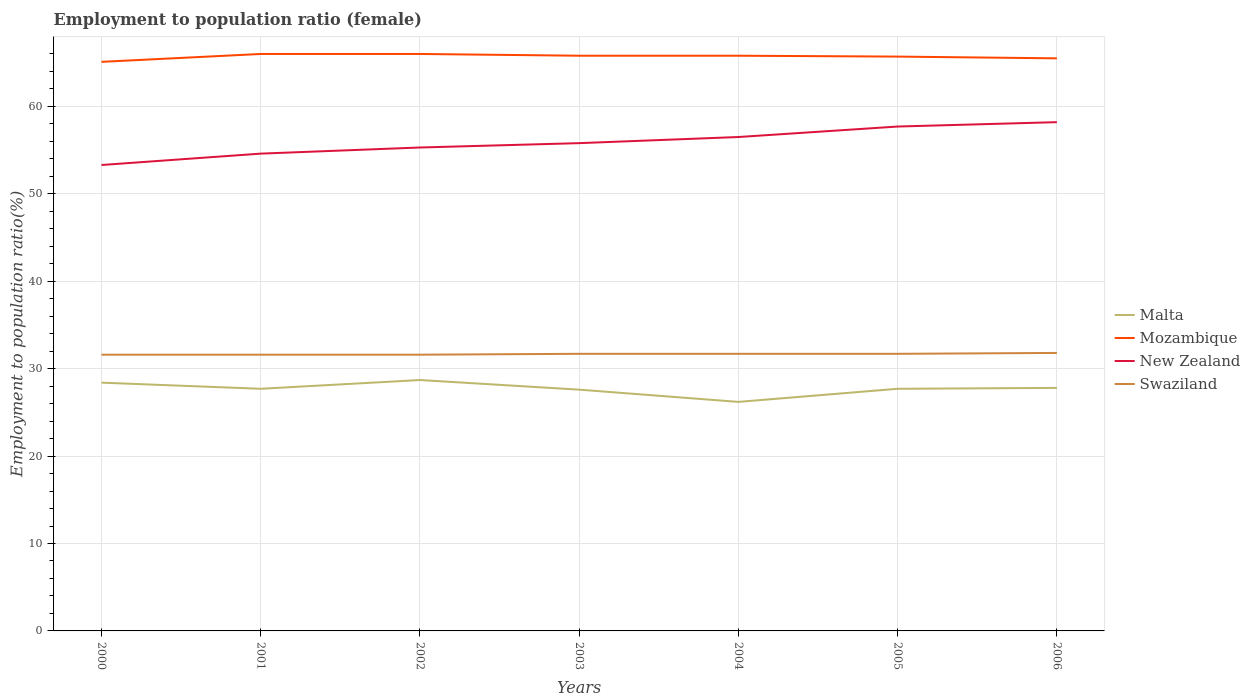How many different coloured lines are there?
Ensure brevity in your answer.  4. Does the line corresponding to Swaziland intersect with the line corresponding to Mozambique?
Your response must be concise. No. Across all years, what is the maximum employment to population ratio in New Zealand?
Your answer should be compact. 53.3. In which year was the employment to population ratio in Mozambique maximum?
Give a very brief answer. 2000. What is the total employment to population ratio in Mozambique in the graph?
Provide a short and direct response. 0.1. What is the difference between the highest and the second highest employment to population ratio in Mozambique?
Offer a terse response. 0.9. What is the difference between the highest and the lowest employment to population ratio in Mozambique?
Your answer should be very brief. 4. Is the employment to population ratio in New Zealand strictly greater than the employment to population ratio in Mozambique over the years?
Your answer should be very brief. Yes. What is the difference between two consecutive major ticks on the Y-axis?
Your answer should be very brief. 10. Are the values on the major ticks of Y-axis written in scientific E-notation?
Keep it short and to the point. No. Where does the legend appear in the graph?
Give a very brief answer. Center right. How many legend labels are there?
Offer a very short reply. 4. How are the legend labels stacked?
Keep it short and to the point. Vertical. What is the title of the graph?
Your answer should be compact. Employment to population ratio (female). Does "Qatar" appear as one of the legend labels in the graph?
Provide a succinct answer. No. What is the label or title of the X-axis?
Offer a terse response. Years. What is the Employment to population ratio(%) of Malta in 2000?
Offer a very short reply. 28.4. What is the Employment to population ratio(%) in Mozambique in 2000?
Offer a very short reply. 65.1. What is the Employment to population ratio(%) in New Zealand in 2000?
Keep it short and to the point. 53.3. What is the Employment to population ratio(%) in Swaziland in 2000?
Make the answer very short. 31.6. What is the Employment to population ratio(%) of Malta in 2001?
Your answer should be compact. 27.7. What is the Employment to population ratio(%) of New Zealand in 2001?
Provide a short and direct response. 54.6. What is the Employment to population ratio(%) in Swaziland in 2001?
Offer a terse response. 31.6. What is the Employment to population ratio(%) of Malta in 2002?
Ensure brevity in your answer.  28.7. What is the Employment to population ratio(%) of Mozambique in 2002?
Provide a succinct answer. 66. What is the Employment to population ratio(%) in New Zealand in 2002?
Provide a succinct answer. 55.3. What is the Employment to population ratio(%) of Swaziland in 2002?
Give a very brief answer. 31.6. What is the Employment to population ratio(%) of Malta in 2003?
Your answer should be very brief. 27.6. What is the Employment to population ratio(%) of Mozambique in 2003?
Your answer should be very brief. 65.8. What is the Employment to population ratio(%) in New Zealand in 2003?
Provide a succinct answer. 55.8. What is the Employment to population ratio(%) in Swaziland in 2003?
Make the answer very short. 31.7. What is the Employment to population ratio(%) in Malta in 2004?
Offer a very short reply. 26.2. What is the Employment to population ratio(%) in Mozambique in 2004?
Offer a very short reply. 65.8. What is the Employment to population ratio(%) in New Zealand in 2004?
Provide a short and direct response. 56.5. What is the Employment to population ratio(%) in Swaziland in 2004?
Keep it short and to the point. 31.7. What is the Employment to population ratio(%) in Malta in 2005?
Your response must be concise. 27.7. What is the Employment to population ratio(%) in Mozambique in 2005?
Provide a succinct answer. 65.7. What is the Employment to population ratio(%) of New Zealand in 2005?
Offer a terse response. 57.7. What is the Employment to population ratio(%) in Swaziland in 2005?
Your answer should be compact. 31.7. What is the Employment to population ratio(%) in Malta in 2006?
Your response must be concise. 27.8. What is the Employment to population ratio(%) in Mozambique in 2006?
Your response must be concise. 65.5. What is the Employment to population ratio(%) of New Zealand in 2006?
Ensure brevity in your answer.  58.2. What is the Employment to population ratio(%) in Swaziland in 2006?
Provide a succinct answer. 31.8. Across all years, what is the maximum Employment to population ratio(%) of Malta?
Your answer should be compact. 28.7. Across all years, what is the maximum Employment to population ratio(%) of Mozambique?
Provide a succinct answer. 66. Across all years, what is the maximum Employment to population ratio(%) of New Zealand?
Your response must be concise. 58.2. Across all years, what is the maximum Employment to population ratio(%) of Swaziland?
Keep it short and to the point. 31.8. Across all years, what is the minimum Employment to population ratio(%) of Malta?
Provide a short and direct response. 26.2. Across all years, what is the minimum Employment to population ratio(%) in Mozambique?
Your answer should be very brief. 65.1. Across all years, what is the minimum Employment to population ratio(%) of New Zealand?
Ensure brevity in your answer.  53.3. Across all years, what is the minimum Employment to population ratio(%) of Swaziland?
Keep it short and to the point. 31.6. What is the total Employment to population ratio(%) of Malta in the graph?
Offer a very short reply. 194.1. What is the total Employment to population ratio(%) of Mozambique in the graph?
Offer a terse response. 459.9. What is the total Employment to population ratio(%) of New Zealand in the graph?
Your answer should be very brief. 391.4. What is the total Employment to population ratio(%) of Swaziland in the graph?
Provide a short and direct response. 221.7. What is the difference between the Employment to population ratio(%) of Malta in 2000 and that in 2001?
Your answer should be very brief. 0.7. What is the difference between the Employment to population ratio(%) of New Zealand in 2000 and that in 2001?
Your response must be concise. -1.3. What is the difference between the Employment to population ratio(%) of Mozambique in 2000 and that in 2002?
Provide a short and direct response. -0.9. What is the difference between the Employment to population ratio(%) in Swaziland in 2000 and that in 2002?
Provide a succinct answer. 0. What is the difference between the Employment to population ratio(%) of Malta in 2000 and that in 2003?
Make the answer very short. 0.8. What is the difference between the Employment to population ratio(%) in Mozambique in 2000 and that in 2003?
Keep it short and to the point. -0.7. What is the difference between the Employment to population ratio(%) in Mozambique in 2000 and that in 2004?
Your response must be concise. -0.7. What is the difference between the Employment to population ratio(%) of Malta in 2000 and that in 2005?
Give a very brief answer. 0.7. What is the difference between the Employment to population ratio(%) of Mozambique in 2000 and that in 2005?
Keep it short and to the point. -0.6. What is the difference between the Employment to population ratio(%) of Malta in 2000 and that in 2006?
Offer a very short reply. 0.6. What is the difference between the Employment to population ratio(%) of Mozambique in 2000 and that in 2006?
Ensure brevity in your answer.  -0.4. What is the difference between the Employment to population ratio(%) in Swaziland in 2000 and that in 2006?
Ensure brevity in your answer.  -0.2. What is the difference between the Employment to population ratio(%) of Malta in 2001 and that in 2002?
Your answer should be very brief. -1. What is the difference between the Employment to population ratio(%) of New Zealand in 2001 and that in 2002?
Offer a very short reply. -0.7. What is the difference between the Employment to population ratio(%) in New Zealand in 2001 and that in 2003?
Provide a succinct answer. -1.2. What is the difference between the Employment to population ratio(%) of Malta in 2001 and that in 2004?
Your answer should be very brief. 1.5. What is the difference between the Employment to population ratio(%) in Mozambique in 2001 and that in 2004?
Offer a very short reply. 0.2. What is the difference between the Employment to population ratio(%) of Mozambique in 2001 and that in 2005?
Your response must be concise. 0.3. What is the difference between the Employment to population ratio(%) in Swaziland in 2001 and that in 2005?
Offer a very short reply. -0.1. What is the difference between the Employment to population ratio(%) of New Zealand in 2001 and that in 2006?
Your response must be concise. -3.6. What is the difference between the Employment to population ratio(%) in Swaziland in 2001 and that in 2006?
Your answer should be compact. -0.2. What is the difference between the Employment to population ratio(%) in Malta in 2002 and that in 2003?
Your response must be concise. 1.1. What is the difference between the Employment to population ratio(%) in Mozambique in 2002 and that in 2003?
Provide a short and direct response. 0.2. What is the difference between the Employment to population ratio(%) in Swaziland in 2002 and that in 2003?
Your answer should be compact. -0.1. What is the difference between the Employment to population ratio(%) of Malta in 2002 and that in 2004?
Make the answer very short. 2.5. What is the difference between the Employment to population ratio(%) of Mozambique in 2002 and that in 2004?
Make the answer very short. 0.2. What is the difference between the Employment to population ratio(%) in New Zealand in 2002 and that in 2004?
Give a very brief answer. -1.2. What is the difference between the Employment to population ratio(%) of Mozambique in 2002 and that in 2005?
Give a very brief answer. 0.3. What is the difference between the Employment to population ratio(%) in New Zealand in 2002 and that in 2005?
Your answer should be very brief. -2.4. What is the difference between the Employment to population ratio(%) in New Zealand in 2002 and that in 2006?
Offer a terse response. -2.9. What is the difference between the Employment to population ratio(%) in Swaziland in 2002 and that in 2006?
Provide a succinct answer. -0.2. What is the difference between the Employment to population ratio(%) of New Zealand in 2003 and that in 2004?
Your answer should be very brief. -0.7. What is the difference between the Employment to population ratio(%) of Malta in 2003 and that in 2005?
Your response must be concise. -0.1. What is the difference between the Employment to population ratio(%) in Mozambique in 2003 and that in 2005?
Keep it short and to the point. 0.1. What is the difference between the Employment to population ratio(%) in New Zealand in 2003 and that in 2006?
Keep it short and to the point. -2.4. What is the difference between the Employment to population ratio(%) in Mozambique in 2004 and that in 2005?
Ensure brevity in your answer.  0.1. What is the difference between the Employment to population ratio(%) in Swaziland in 2004 and that in 2005?
Your answer should be very brief. 0. What is the difference between the Employment to population ratio(%) in Malta in 2004 and that in 2006?
Offer a terse response. -1.6. What is the difference between the Employment to population ratio(%) in Mozambique in 2004 and that in 2006?
Provide a succinct answer. 0.3. What is the difference between the Employment to population ratio(%) in New Zealand in 2004 and that in 2006?
Your answer should be very brief. -1.7. What is the difference between the Employment to population ratio(%) of Swaziland in 2004 and that in 2006?
Offer a terse response. -0.1. What is the difference between the Employment to population ratio(%) in New Zealand in 2005 and that in 2006?
Ensure brevity in your answer.  -0.5. What is the difference between the Employment to population ratio(%) of Malta in 2000 and the Employment to population ratio(%) of Mozambique in 2001?
Ensure brevity in your answer.  -37.6. What is the difference between the Employment to population ratio(%) of Malta in 2000 and the Employment to population ratio(%) of New Zealand in 2001?
Ensure brevity in your answer.  -26.2. What is the difference between the Employment to population ratio(%) of Malta in 2000 and the Employment to population ratio(%) of Swaziland in 2001?
Provide a short and direct response. -3.2. What is the difference between the Employment to population ratio(%) of Mozambique in 2000 and the Employment to population ratio(%) of New Zealand in 2001?
Your answer should be very brief. 10.5. What is the difference between the Employment to population ratio(%) in Mozambique in 2000 and the Employment to population ratio(%) in Swaziland in 2001?
Offer a terse response. 33.5. What is the difference between the Employment to population ratio(%) of New Zealand in 2000 and the Employment to population ratio(%) of Swaziland in 2001?
Offer a very short reply. 21.7. What is the difference between the Employment to population ratio(%) of Malta in 2000 and the Employment to population ratio(%) of Mozambique in 2002?
Offer a terse response. -37.6. What is the difference between the Employment to population ratio(%) of Malta in 2000 and the Employment to population ratio(%) of New Zealand in 2002?
Keep it short and to the point. -26.9. What is the difference between the Employment to population ratio(%) of Mozambique in 2000 and the Employment to population ratio(%) of New Zealand in 2002?
Your answer should be very brief. 9.8. What is the difference between the Employment to population ratio(%) of Mozambique in 2000 and the Employment to population ratio(%) of Swaziland in 2002?
Ensure brevity in your answer.  33.5. What is the difference between the Employment to population ratio(%) in New Zealand in 2000 and the Employment to population ratio(%) in Swaziland in 2002?
Offer a terse response. 21.7. What is the difference between the Employment to population ratio(%) of Malta in 2000 and the Employment to population ratio(%) of Mozambique in 2003?
Offer a very short reply. -37.4. What is the difference between the Employment to population ratio(%) of Malta in 2000 and the Employment to population ratio(%) of New Zealand in 2003?
Your answer should be compact. -27.4. What is the difference between the Employment to population ratio(%) in Mozambique in 2000 and the Employment to population ratio(%) in New Zealand in 2003?
Your answer should be compact. 9.3. What is the difference between the Employment to population ratio(%) of Mozambique in 2000 and the Employment to population ratio(%) of Swaziland in 2003?
Provide a short and direct response. 33.4. What is the difference between the Employment to population ratio(%) in New Zealand in 2000 and the Employment to population ratio(%) in Swaziland in 2003?
Provide a short and direct response. 21.6. What is the difference between the Employment to population ratio(%) of Malta in 2000 and the Employment to population ratio(%) of Mozambique in 2004?
Your answer should be compact. -37.4. What is the difference between the Employment to population ratio(%) in Malta in 2000 and the Employment to population ratio(%) in New Zealand in 2004?
Offer a terse response. -28.1. What is the difference between the Employment to population ratio(%) of Malta in 2000 and the Employment to population ratio(%) of Swaziland in 2004?
Your response must be concise. -3.3. What is the difference between the Employment to population ratio(%) of Mozambique in 2000 and the Employment to population ratio(%) of New Zealand in 2004?
Provide a short and direct response. 8.6. What is the difference between the Employment to population ratio(%) of Mozambique in 2000 and the Employment to population ratio(%) of Swaziland in 2004?
Give a very brief answer. 33.4. What is the difference between the Employment to population ratio(%) of New Zealand in 2000 and the Employment to population ratio(%) of Swaziland in 2004?
Your response must be concise. 21.6. What is the difference between the Employment to population ratio(%) in Malta in 2000 and the Employment to population ratio(%) in Mozambique in 2005?
Offer a very short reply. -37.3. What is the difference between the Employment to population ratio(%) in Malta in 2000 and the Employment to population ratio(%) in New Zealand in 2005?
Offer a terse response. -29.3. What is the difference between the Employment to population ratio(%) of Malta in 2000 and the Employment to population ratio(%) of Swaziland in 2005?
Keep it short and to the point. -3.3. What is the difference between the Employment to population ratio(%) of Mozambique in 2000 and the Employment to population ratio(%) of Swaziland in 2005?
Your response must be concise. 33.4. What is the difference between the Employment to population ratio(%) in New Zealand in 2000 and the Employment to population ratio(%) in Swaziland in 2005?
Make the answer very short. 21.6. What is the difference between the Employment to population ratio(%) of Malta in 2000 and the Employment to population ratio(%) of Mozambique in 2006?
Ensure brevity in your answer.  -37.1. What is the difference between the Employment to population ratio(%) in Malta in 2000 and the Employment to population ratio(%) in New Zealand in 2006?
Provide a short and direct response. -29.8. What is the difference between the Employment to population ratio(%) of Mozambique in 2000 and the Employment to population ratio(%) of Swaziland in 2006?
Keep it short and to the point. 33.3. What is the difference between the Employment to population ratio(%) in Malta in 2001 and the Employment to population ratio(%) in Mozambique in 2002?
Make the answer very short. -38.3. What is the difference between the Employment to population ratio(%) of Malta in 2001 and the Employment to population ratio(%) of New Zealand in 2002?
Give a very brief answer. -27.6. What is the difference between the Employment to population ratio(%) in Mozambique in 2001 and the Employment to population ratio(%) in Swaziland in 2002?
Make the answer very short. 34.4. What is the difference between the Employment to population ratio(%) of Malta in 2001 and the Employment to population ratio(%) of Mozambique in 2003?
Offer a terse response. -38.1. What is the difference between the Employment to population ratio(%) of Malta in 2001 and the Employment to population ratio(%) of New Zealand in 2003?
Make the answer very short. -28.1. What is the difference between the Employment to population ratio(%) of Mozambique in 2001 and the Employment to population ratio(%) of New Zealand in 2003?
Your answer should be compact. 10.2. What is the difference between the Employment to population ratio(%) in Mozambique in 2001 and the Employment to population ratio(%) in Swaziland in 2003?
Your answer should be compact. 34.3. What is the difference between the Employment to population ratio(%) of New Zealand in 2001 and the Employment to population ratio(%) of Swaziland in 2003?
Your answer should be very brief. 22.9. What is the difference between the Employment to population ratio(%) in Malta in 2001 and the Employment to population ratio(%) in Mozambique in 2004?
Keep it short and to the point. -38.1. What is the difference between the Employment to population ratio(%) in Malta in 2001 and the Employment to population ratio(%) in New Zealand in 2004?
Ensure brevity in your answer.  -28.8. What is the difference between the Employment to population ratio(%) in Malta in 2001 and the Employment to population ratio(%) in Swaziland in 2004?
Give a very brief answer. -4. What is the difference between the Employment to population ratio(%) in Mozambique in 2001 and the Employment to population ratio(%) in New Zealand in 2004?
Ensure brevity in your answer.  9.5. What is the difference between the Employment to population ratio(%) in Mozambique in 2001 and the Employment to population ratio(%) in Swaziland in 2004?
Make the answer very short. 34.3. What is the difference between the Employment to population ratio(%) of New Zealand in 2001 and the Employment to population ratio(%) of Swaziland in 2004?
Ensure brevity in your answer.  22.9. What is the difference between the Employment to population ratio(%) of Malta in 2001 and the Employment to population ratio(%) of Mozambique in 2005?
Make the answer very short. -38. What is the difference between the Employment to population ratio(%) in Mozambique in 2001 and the Employment to population ratio(%) in New Zealand in 2005?
Your response must be concise. 8.3. What is the difference between the Employment to population ratio(%) of Mozambique in 2001 and the Employment to population ratio(%) of Swaziland in 2005?
Provide a succinct answer. 34.3. What is the difference between the Employment to population ratio(%) of New Zealand in 2001 and the Employment to population ratio(%) of Swaziland in 2005?
Provide a succinct answer. 22.9. What is the difference between the Employment to population ratio(%) in Malta in 2001 and the Employment to population ratio(%) in Mozambique in 2006?
Provide a short and direct response. -37.8. What is the difference between the Employment to population ratio(%) in Malta in 2001 and the Employment to population ratio(%) in New Zealand in 2006?
Give a very brief answer. -30.5. What is the difference between the Employment to population ratio(%) of Mozambique in 2001 and the Employment to population ratio(%) of New Zealand in 2006?
Make the answer very short. 7.8. What is the difference between the Employment to population ratio(%) of Mozambique in 2001 and the Employment to population ratio(%) of Swaziland in 2006?
Give a very brief answer. 34.2. What is the difference between the Employment to population ratio(%) in New Zealand in 2001 and the Employment to population ratio(%) in Swaziland in 2006?
Keep it short and to the point. 22.8. What is the difference between the Employment to population ratio(%) in Malta in 2002 and the Employment to population ratio(%) in Mozambique in 2003?
Keep it short and to the point. -37.1. What is the difference between the Employment to population ratio(%) in Malta in 2002 and the Employment to population ratio(%) in New Zealand in 2003?
Give a very brief answer. -27.1. What is the difference between the Employment to population ratio(%) of Mozambique in 2002 and the Employment to population ratio(%) of Swaziland in 2003?
Offer a very short reply. 34.3. What is the difference between the Employment to population ratio(%) in New Zealand in 2002 and the Employment to population ratio(%) in Swaziland in 2003?
Give a very brief answer. 23.6. What is the difference between the Employment to population ratio(%) of Malta in 2002 and the Employment to population ratio(%) of Mozambique in 2004?
Give a very brief answer. -37.1. What is the difference between the Employment to population ratio(%) of Malta in 2002 and the Employment to population ratio(%) of New Zealand in 2004?
Give a very brief answer. -27.8. What is the difference between the Employment to population ratio(%) in Mozambique in 2002 and the Employment to population ratio(%) in Swaziland in 2004?
Your answer should be very brief. 34.3. What is the difference between the Employment to population ratio(%) in New Zealand in 2002 and the Employment to population ratio(%) in Swaziland in 2004?
Your answer should be compact. 23.6. What is the difference between the Employment to population ratio(%) of Malta in 2002 and the Employment to population ratio(%) of Mozambique in 2005?
Your answer should be very brief. -37. What is the difference between the Employment to population ratio(%) of Mozambique in 2002 and the Employment to population ratio(%) of Swaziland in 2005?
Provide a short and direct response. 34.3. What is the difference between the Employment to population ratio(%) in New Zealand in 2002 and the Employment to population ratio(%) in Swaziland in 2005?
Keep it short and to the point. 23.6. What is the difference between the Employment to population ratio(%) of Malta in 2002 and the Employment to population ratio(%) of Mozambique in 2006?
Give a very brief answer. -36.8. What is the difference between the Employment to population ratio(%) of Malta in 2002 and the Employment to population ratio(%) of New Zealand in 2006?
Your response must be concise. -29.5. What is the difference between the Employment to population ratio(%) in Mozambique in 2002 and the Employment to population ratio(%) in New Zealand in 2006?
Offer a very short reply. 7.8. What is the difference between the Employment to population ratio(%) in Mozambique in 2002 and the Employment to population ratio(%) in Swaziland in 2006?
Offer a terse response. 34.2. What is the difference between the Employment to population ratio(%) of Malta in 2003 and the Employment to population ratio(%) of Mozambique in 2004?
Make the answer very short. -38.2. What is the difference between the Employment to population ratio(%) in Malta in 2003 and the Employment to population ratio(%) in New Zealand in 2004?
Give a very brief answer. -28.9. What is the difference between the Employment to population ratio(%) of Mozambique in 2003 and the Employment to population ratio(%) of Swaziland in 2004?
Your answer should be compact. 34.1. What is the difference between the Employment to population ratio(%) of New Zealand in 2003 and the Employment to population ratio(%) of Swaziland in 2004?
Your answer should be compact. 24.1. What is the difference between the Employment to population ratio(%) of Malta in 2003 and the Employment to population ratio(%) of Mozambique in 2005?
Offer a terse response. -38.1. What is the difference between the Employment to population ratio(%) in Malta in 2003 and the Employment to population ratio(%) in New Zealand in 2005?
Give a very brief answer. -30.1. What is the difference between the Employment to population ratio(%) in Mozambique in 2003 and the Employment to population ratio(%) in New Zealand in 2005?
Provide a short and direct response. 8.1. What is the difference between the Employment to population ratio(%) of Mozambique in 2003 and the Employment to population ratio(%) of Swaziland in 2005?
Provide a short and direct response. 34.1. What is the difference between the Employment to population ratio(%) of New Zealand in 2003 and the Employment to population ratio(%) of Swaziland in 2005?
Give a very brief answer. 24.1. What is the difference between the Employment to population ratio(%) in Malta in 2003 and the Employment to population ratio(%) in Mozambique in 2006?
Offer a terse response. -37.9. What is the difference between the Employment to population ratio(%) of Malta in 2003 and the Employment to population ratio(%) of New Zealand in 2006?
Provide a short and direct response. -30.6. What is the difference between the Employment to population ratio(%) of Mozambique in 2003 and the Employment to population ratio(%) of New Zealand in 2006?
Give a very brief answer. 7.6. What is the difference between the Employment to population ratio(%) of New Zealand in 2003 and the Employment to population ratio(%) of Swaziland in 2006?
Offer a very short reply. 24. What is the difference between the Employment to population ratio(%) of Malta in 2004 and the Employment to population ratio(%) of Mozambique in 2005?
Provide a short and direct response. -39.5. What is the difference between the Employment to population ratio(%) of Malta in 2004 and the Employment to population ratio(%) of New Zealand in 2005?
Offer a very short reply. -31.5. What is the difference between the Employment to population ratio(%) of Malta in 2004 and the Employment to population ratio(%) of Swaziland in 2005?
Provide a short and direct response. -5.5. What is the difference between the Employment to population ratio(%) of Mozambique in 2004 and the Employment to population ratio(%) of Swaziland in 2005?
Make the answer very short. 34.1. What is the difference between the Employment to population ratio(%) in New Zealand in 2004 and the Employment to population ratio(%) in Swaziland in 2005?
Provide a short and direct response. 24.8. What is the difference between the Employment to population ratio(%) of Malta in 2004 and the Employment to population ratio(%) of Mozambique in 2006?
Your response must be concise. -39.3. What is the difference between the Employment to population ratio(%) of Malta in 2004 and the Employment to population ratio(%) of New Zealand in 2006?
Keep it short and to the point. -32. What is the difference between the Employment to population ratio(%) of Mozambique in 2004 and the Employment to population ratio(%) of New Zealand in 2006?
Provide a succinct answer. 7.6. What is the difference between the Employment to population ratio(%) in Mozambique in 2004 and the Employment to population ratio(%) in Swaziland in 2006?
Your answer should be very brief. 34. What is the difference between the Employment to population ratio(%) of New Zealand in 2004 and the Employment to population ratio(%) of Swaziland in 2006?
Your answer should be compact. 24.7. What is the difference between the Employment to population ratio(%) in Malta in 2005 and the Employment to population ratio(%) in Mozambique in 2006?
Offer a terse response. -37.8. What is the difference between the Employment to population ratio(%) in Malta in 2005 and the Employment to population ratio(%) in New Zealand in 2006?
Your answer should be very brief. -30.5. What is the difference between the Employment to population ratio(%) in Malta in 2005 and the Employment to population ratio(%) in Swaziland in 2006?
Ensure brevity in your answer.  -4.1. What is the difference between the Employment to population ratio(%) of Mozambique in 2005 and the Employment to population ratio(%) of Swaziland in 2006?
Provide a succinct answer. 33.9. What is the difference between the Employment to population ratio(%) of New Zealand in 2005 and the Employment to population ratio(%) of Swaziland in 2006?
Give a very brief answer. 25.9. What is the average Employment to population ratio(%) of Malta per year?
Provide a succinct answer. 27.73. What is the average Employment to population ratio(%) in Mozambique per year?
Keep it short and to the point. 65.7. What is the average Employment to population ratio(%) of New Zealand per year?
Keep it short and to the point. 55.91. What is the average Employment to population ratio(%) in Swaziland per year?
Provide a short and direct response. 31.67. In the year 2000, what is the difference between the Employment to population ratio(%) in Malta and Employment to population ratio(%) in Mozambique?
Your answer should be very brief. -36.7. In the year 2000, what is the difference between the Employment to population ratio(%) of Malta and Employment to population ratio(%) of New Zealand?
Your answer should be very brief. -24.9. In the year 2000, what is the difference between the Employment to population ratio(%) of Mozambique and Employment to population ratio(%) of Swaziland?
Provide a succinct answer. 33.5. In the year 2000, what is the difference between the Employment to population ratio(%) of New Zealand and Employment to population ratio(%) of Swaziland?
Keep it short and to the point. 21.7. In the year 2001, what is the difference between the Employment to population ratio(%) of Malta and Employment to population ratio(%) of Mozambique?
Give a very brief answer. -38.3. In the year 2001, what is the difference between the Employment to population ratio(%) in Malta and Employment to population ratio(%) in New Zealand?
Offer a terse response. -26.9. In the year 2001, what is the difference between the Employment to population ratio(%) of Malta and Employment to population ratio(%) of Swaziland?
Keep it short and to the point. -3.9. In the year 2001, what is the difference between the Employment to population ratio(%) in Mozambique and Employment to population ratio(%) in New Zealand?
Offer a very short reply. 11.4. In the year 2001, what is the difference between the Employment to population ratio(%) of Mozambique and Employment to population ratio(%) of Swaziland?
Your answer should be compact. 34.4. In the year 2002, what is the difference between the Employment to population ratio(%) in Malta and Employment to population ratio(%) in Mozambique?
Offer a terse response. -37.3. In the year 2002, what is the difference between the Employment to population ratio(%) in Malta and Employment to population ratio(%) in New Zealand?
Your answer should be compact. -26.6. In the year 2002, what is the difference between the Employment to population ratio(%) in Malta and Employment to population ratio(%) in Swaziland?
Give a very brief answer. -2.9. In the year 2002, what is the difference between the Employment to population ratio(%) of Mozambique and Employment to population ratio(%) of Swaziland?
Offer a terse response. 34.4. In the year 2002, what is the difference between the Employment to population ratio(%) of New Zealand and Employment to population ratio(%) of Swaziland?
Provide a short and direct response. 23.7. In the year 2003, what is the difference between the Employment to population ratio(%) in Malta and Employment to population ratio(%) in Mozambique?
Your answer should be compact. -38.2. In the year 2003, what is the difference between the Employment to population ratio(%) in Malta and Employment to population ratio(%) in New Zealand?
Offer a very short reply. -28.2. In the year 2003, what is the difference between the Employment to population ratio(%) of Mozambique and Employment to population ratio(%) of New Zealand?
Ensure brevity in your answer.  10. In the year 2003, what is the difference between the Employment to population ratio(%) of Mozambique and Employment to population ratio(%) of Swaziland?
Your answer should be very brief. 34.1. In the year 2003, what is the difference between the Employment to population ratio(%) in New Zealand and Employment to population ratio(%) in Swaziland?
Your answer should be compact. 24.1. In the year 2004, what is the difference between the Employment to population ratio(%) in Malta and Employment to population ratio(%) in Mozambique?
Ensure brevity in your answer.  -39.6. In the year 2004, what is the difference between the Employment to population ratio(%) of Malta and Employment to population ratio(%) of New Zealand?
Offer a very short reply. -30.3. In the year 2004, what is the difference between the Employment to population ratio(%) of Malta and Employment to population ratio(%) of Swaziland?
Make the answer very short. -5.5. In the year 2004, what is the difference between the Employment to population ratio(%) of Mozambique and Employment to population ratio(%) of Swaziland?
Make the answer very short. 34.1. In the year 2004, what is the difference between the Employment to population ratio(%) in New Zealand and Employment to population ratio(%) in Swaziland?
Give a very brief answer. 24.8. In the year 2005, what is the difference between the Employment to population ratio(%) in Malta and Employment to population ratio(%) in Mozambique?
Give a very brief answer. -38. In the year 2005, what is the difference between the Employment to population ratio(%) of Malta and Employment to population ratio(%) of New Zealand?
Your answer should be compact. -30. In the year 2005, what is the difference between the Employment to population ratio(%) in Malta and Employment to population ratio(%) in Swaziland?
Ensure brevity in your answer.  -4. In the year 2005, what is the difference between the Employment to population ratio(%) in Mozambique and Employment to population ratio(%) in New Zealand?
Provide a short and direct response. 8. In the year 2005, what is the difference between the Employment to population ratio(%) in Mozambique and Employment to population ratio(%) in Swaziland?
Your answer should be compact. 34. In the year 2005, what is the difference between the Employment to population ratio(%) in New Zealand and Employment to population ratio(%) in Swaziland?
Your answer should be compact. 26. In the year 2006, what is the difference between the Employment to population ratio(%) of Malta and Employment to population ratio(%) of Mozambique?
Keep it short and to the point. -37.7. In the year 2006, what is the difference between the Employment to population ratio(%) in Malta and Employment to population ratio(%) in New Zealand?
Your answer should be compact. -30.4. In the year 2006, what is the difference between the Employment to population ratio(%) in Mozambique and Employment to population ratio(%) in Swaziland?
Offer a terse response. 33.7. In the year 2006, what is the difference between the Employment to population ratio(%) of New Zealand and Employment to population ratio(%) of Swaziland?
Keep it short and to the point. 26.4. What is the ratio of the Employment to population ratio(%) of Malta in 2000 to that in 2001?
Ensure brevity in your answer.  1.03. What is the ratio of the Employment to population ratio(%) in Mozambique in 2000 to that in 2001?
Your response must be concise. 0.99. What is the ratio of the Employment to population ratio(%) in New Zealand in 2000 to that in 2001?
Provide a succinct answer. 0.98. What is the ratio of the Employment to population ratio(%) of Mozambique in 2000 to that in 2002?
Provide a succinct answer. 0.99. What is the ratio of the Employment to population ratio(%) of New Zealand in 2000 to that in 2002?
Offer a terse response. 0.96. What is the ratio of the Employment to population ratio(%) in Swaziland in 2000 to that in 2002?
Your response must be concise. 1. What is the ratio of the Employment to population ratio(%) of Malta in 2000 to that in 2003?
Provide a short and direct response. 1.03. What is the ratio of the Employment to population ratio(%) of New Zealand in 2000 to that in 2003?
Provide a succinct answer. 0.96. What is the ratio of the Employment to population ratio(%) in Malta in 2000 to that in 2004?
Provide a succinct answer. 1.08. What is the ratio of the Employment to population ratio(%) of Mozambique in 2000 to that in 2004?
Your answer should be very brief. 0.99. What is the ratio of the Employment to population ratio(%) in New Zealand in 2000 to that in 2004?
Make the answer very short. 0.94. What is the ratio of the Employment to population ratio(%) of Swaziland in 2000 to that in 2004?
Keep it short and to the point. 1. What is the ratio of the Employment to population ratio(%) in Malta in 2000 to that in 2005?
Ensure brevity in your answer.  1.03. What is the ratio of the Employment to population ratio(%) in Mozambique in 2000 to that in 2005?
Your answer should be compact. 0.99. What is the ratio of the Employment to population ratio(%) in New Zealand in 2000 to that in 2005?
Keep it short and to the point. 0.92. What is the ratio of the Employment to population ratio(%) in Malta in 2000 to that in 2006?
Your response must be concise. 1.02. What is the ratio of the Employment to population ratio(%) in Mozambique in 2000 to that in 2006?
Your answer should be very brief. 0.99. What is the ratio of the Employment to population ratio(%) in New Zealand in 2000 to that in 2006?
Give a very brief answer. 0.92. What is the ratio of the Employment to population ratio(%) in Swaziland in 2000 to that in 2006?
Ensure brevity in your answer.  0.99. What is the ratio of the Employment to population ratio(%) of Malta in 2001 to that in 2002?
Offer a very short reply. 0.97. What is the ratio of the Employment to population ratio(%) in Mozambique in 2001 to that in 2002?
Ensure brevity in your answer.  1. What is the ratio of the Employment to population ratio(%) of New Zealand in 2001 to that in 2002?
Provide a succinct answer. 0.99. What is the ratio of the Employment to population ratio(%) in Malta in 2001 to that in 2003?
Make the answer very short. 1. What is the ratio of the Employment to population ratio(%) in New Zealand in 2001 to that in 2003?
Ensure brevity in your answer.  0.98. What is the ratio of the Employment to population ratio(%) in Swaziland in 2001 to that in 2003?
Your answer should be compact. 1. What is the ratio of the Employment to population ratio(%) in Malta in 2001 to that in 2004?
Make the answer very short. 1.06. What is the ratio of the Employment to population ratio(%) of Mozambique in 2001 to that in 2004?
Provide a succinct answer. 1. What is the ratio of the Employment to population ratio(%) in New Zealand in 2001 to that in 2004?
Your answer should be very brief. 0.97. What is the ratio of the Employment to population ratio(%) in New Zealand in 2001 to that in 2005?
Your answer should be compact. 0.95. What is the ratio of the Employment to population ratio(%) of Swaziland in 2001 to that in 2005?
Your answer should be compact. 1. What is the ratio of the Employment to population ratio(%) of Mozambique in 2001 to that in 2006?
Your answer should be very brief. 1.01. What is the ratio of the Employment to population ratio(%) in New Zealand in 2001 to that in 2006?
Offer a very short reply. 0.94. What is the ratio of the Employment to population ratio(%) in Malta in 2002 to that in 2003?
Your answer should be compact. 1.04. What is the ratio of the Employment to population ratio(%) in New Zealand in 2002 to that in 2003?
Your answer should be very brief. 0.99. What is the ratio of the Employment to population ratio(%) in Malta in 2002 to that in 2004?
Make the answer very short. 1.1. What is the ratio of the Employment to population ratio(%) in Mozambique in 2002 to that in 2004?
Provide a succinct answer. 1. What is the ratio of the Employment to population ratio(%) of New Zealand in 2002 to that in 2004?
Ensure brevity in your answer.  0.98. What is the ratio of the Employment to population ratio(%) in Swaziland in 2002 to that in 2004?
Offer a terse response. 1. What is the ratio of the Employment to population ratio(%) in Malta in 2002 to that in 2005?
Make the answer very short. 1.04. What is the ratio of the Employment to population ratio(%) of Mozambique in 2002 to that in 2005?
Keep it short and to the point. 1. What is the ratio of the Employment to population ratio(%) of New Zealand in 2002 to that in 2005?
Your answer should be very brief. 0.96. What is the ratio of the Employment to population ratio(%) in Malta in 2002 to that in 2006?
Your answer should be compact. 1.03. What is the ratio of the Employment to population ratio(%) in Mozambique in 2002 to that in 2006?
Provide a short and direct response. 1.01. What is the ratio of the Employment to population ratio(%) in New Zealand in 2002 to that in 2006?
Provide a short and direct response. 0.95. What is the ratio of the Employment to population ratio(%) of Swaziland in 2002 to that in 2006?
Provide a short and direct response. 0.99. What is the ratio of the Employment to population ratio(%) of Malta in 2003 to that in 2004?
Offer a terse response. 1.05. What is the ratio of the Employment to population ratio(%) in New Zealand in 2003 to that in 2004?
Ensure brevity in your answer.  0.99. What is the ratio of the Employment to population ratio(%) in Swaziland in 2003 to that in 2004?
Offer a terse response. 1. What is the ratio of the Employment to population ratio(%) of Malta in 2003 to that in 2005?
Make the answer very short. 1. What is the ratio of the Employment to population ratio(%) in New Zealand in 2003 to that in 2005?
Offer a very short reply. 0.97. What is the ratio of the Employment to population ratio(%) in Malta in 2003 to that in 2006?
Ensure brevity in your answer.  0.99. What is the ratio of the Employment to population ratio(%) of New Zealand in 2003 to that in 2006?
Your answer should be compact. 0.96. What is the ratio of the Employment to population ratio(%) of Swaziland in 2003 to that in 2006?
Make the answer very short. 1. What is the ratio of the Employment to population ratio(%) of Malta in 2004 to that in 2005?
Offer a very short reply. 0.95. What is the ratio of the Employment to population ratio(%) in New Zealand in 2004 to that in 2005?
Give a very brief answer. 0.98. What is the ratio of the Employment to population ratio(%) of Swaziland in 2004 to that in 2005?
Give a very brief answer. 1. What is the ratio of the Employment to population ratio(%) in Malta in 2004 to that in 2006?
Your answer should be very brief. 0.94. What is the ratio of the Employment to population ratio(%) in Mozambique in 2004 to that in 2006?
Your response must be concise. 1. What is the ratio of the Employment to population ratio(%) of New Zealand in 2004 to that in 2006?
Offer a terse response. 0.97. What is the ratio of the Employment to population ratio(%) of Mozambique in 2005 to that in 2006?
Your answer should be very brief. 1. What is the difference between the highest and the second highest Employment to population ratio(%) in Malta?
Ensure brevity in your answer.  0.3. What is the difference between the highest and the second highest Employment to population ratio(%) in Mozambique?
Provide a short and direct response. 0. What is the difference between the highest and the second highest Employment to population ratio(%) in New Zealand?
Keep it short and to the point. 0.5. What is the difference between the highest and the second highest Employment to population ratio(%) of Swaziland?
Give a very brief answer. 0.1. What is the difference between the highest and the lowest Employment to population ratio(%) in Mozambique?
Ensure brevity in your answer.  0.9. What is the difference between the highest and the lowest Employment to population ratio(%) of New Zealand?
Provide a short and direct response. 4.9. 